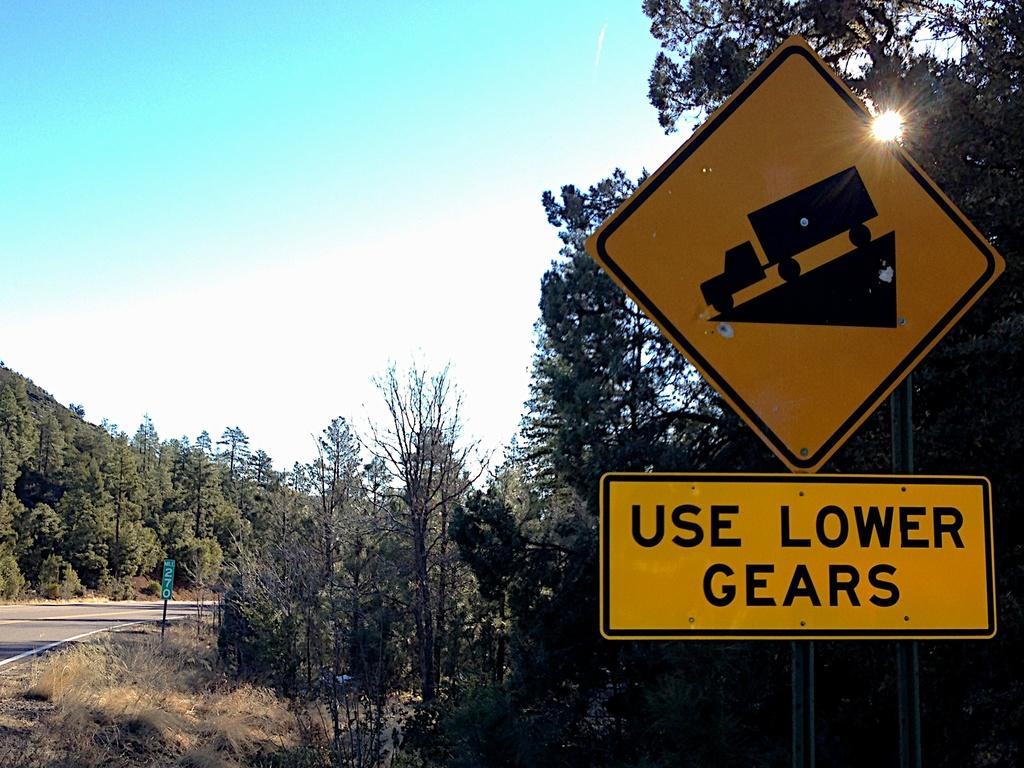<image>
Create a compact narrative representing the image presented. A road sign telling large trucks to use lower gears on the downward incline. 